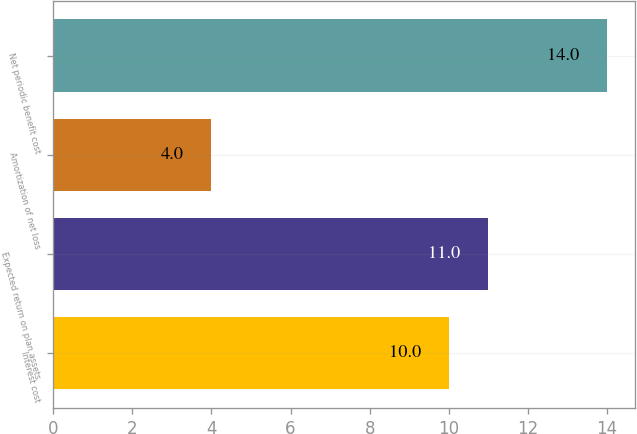Convert chart to OTSL. <chart><loc_0><loc_0><loc_500><loc_500><bar_chart><fcel>Interest cost<fcel>Expected return on plan assets<fcel>Amortization of net loss<fcel>Net periodic benefit cost<nl><fcel>10<fcel>11<fcel>4<fcel>14<nl></chart> 